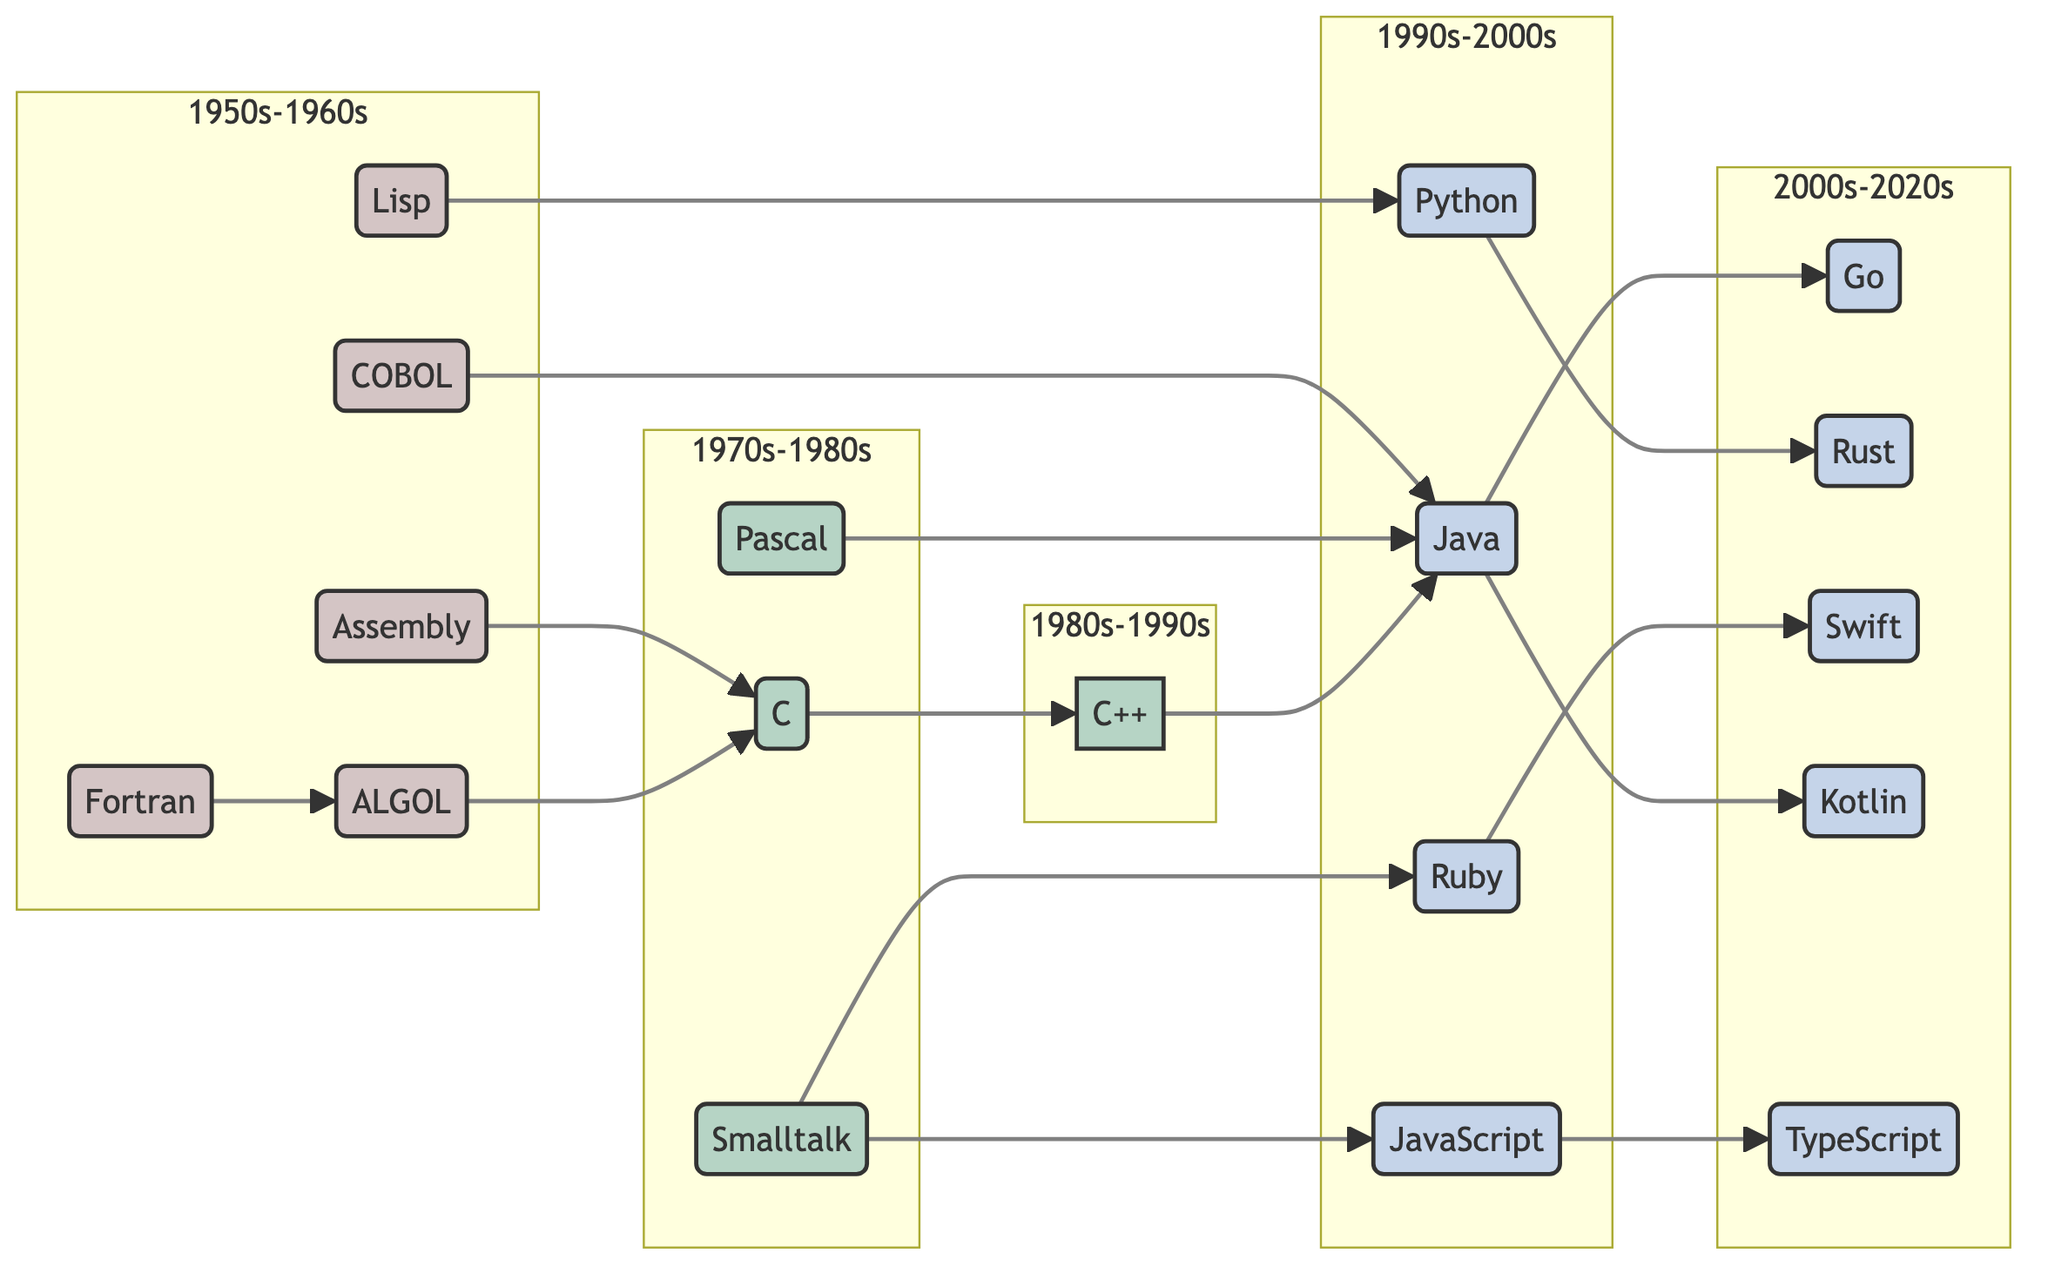What are the oldest programming languages in the diagram? The oldest programming languages in the diagram are Assembly, Fortran, COBOL, Lisp, and ALGOL. They are grouped in the 1950s-1960s subgraph, indicating their emergence during that period.
Answer: Assembly, Fortran, COBOL, Lisp, ALGOL How many programming languages are listed in total within the diagram? The diagram displays a total of 17 programming language nodes. This total can be counted from the nodes section of the provided data.
Answer: 17 Which language does Python evolve from? In the diagram, Python is shown to evolve from Lisp, as indicated by the edge leading from Lisp to Python.
Answer: Lisp What is the relationship between C and C++? The relationship between C and C++ is that C is a predecessor of C++, which is shown by the directed edge from C to C++.
Answer: C How many languages are related directly to Java? There are three languages related directly to Java: Kotlin, Go, and C++. This can be counted by looking at the outgoing edges from the Java node.
Answer: 3 Which programming language has the most outgoing connections? The programming language that has the most outgoing connections is Java, which connects to Kotlin, Go, and C++. This can be identified by counting the edges originating from the Java node.
Answer: Java What color represents the oldest era of programming languages in the diagram? The oldest era of programming languages, represented by languages from the 1950s-1960s, is colored in a light red shade which differentiates it from other time periods.
Answer: Light red Which language is considered a child of Smalltalk? Smalltalk has two children in the diagram: Ruby and JavaScript, as indicated by the edges leading from Smalltalk to each of these languages.
Answer: Ruby, JavaScript What is the most recent programming language developed according to the diagram? The most recent programming language identified in the diagram is TypeScript, which falls under the 2000s-2020s era. This is based on its placement in the latest subgraph.
Answer: TypeScript 